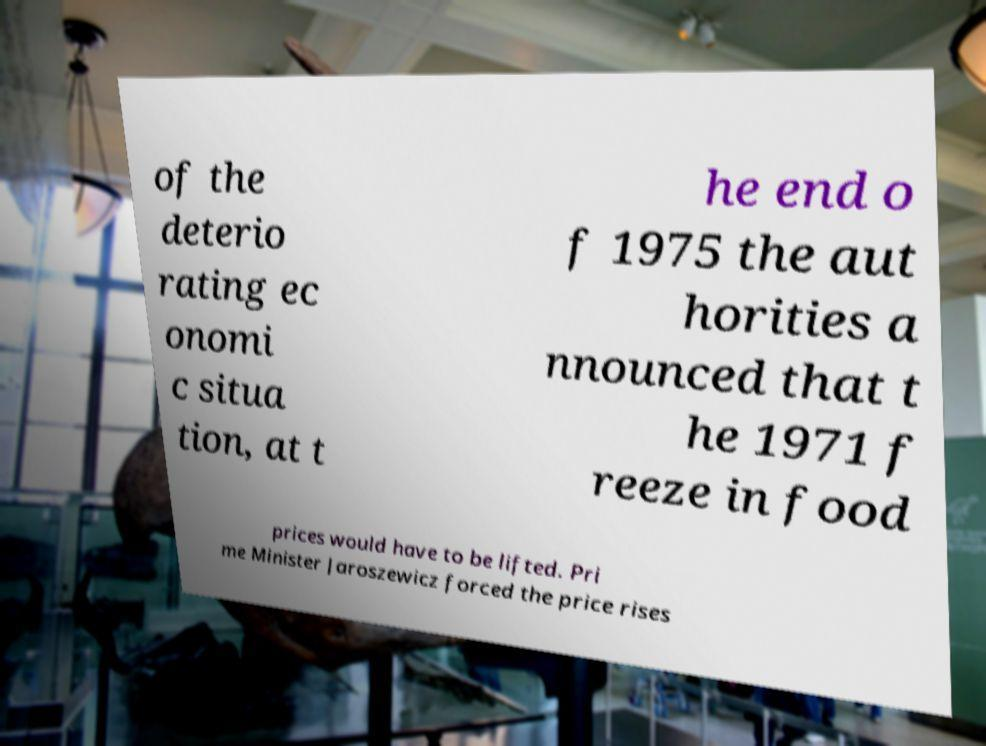Could you extract and type out the text from this image? of the deterio rating ec onomi c situa tion, at t he end o f 1975 the aut horities a nnounced that t he 1971 f reeze in food prices would have to be lifted. Pri me Minister Jaroszewicz forced the price rises 